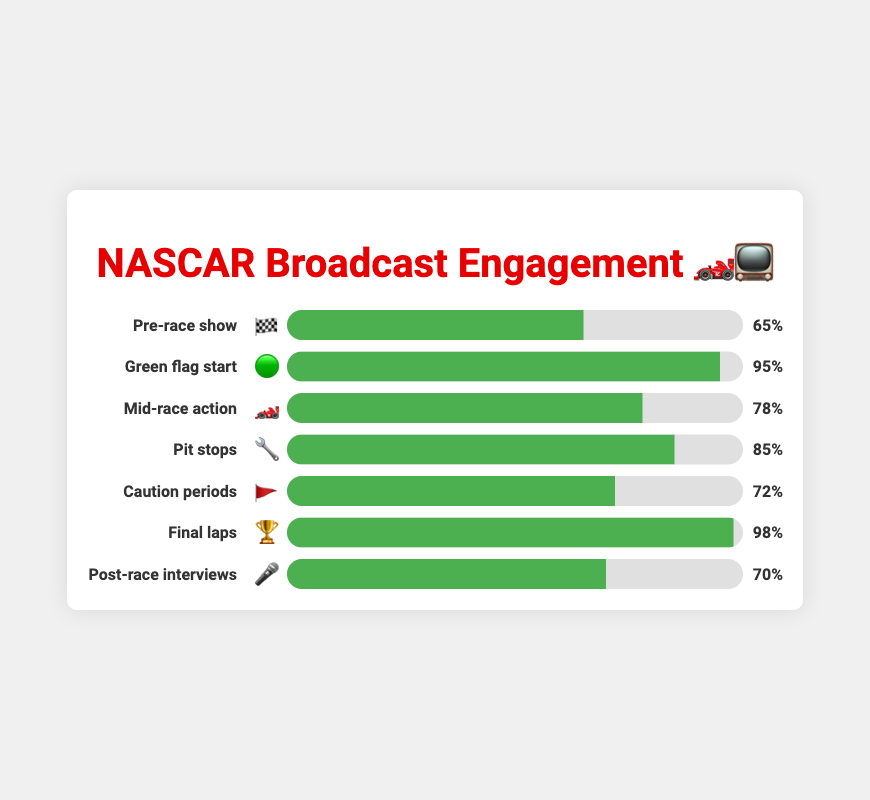What is the engagement rating for the Green flag start 🟢? The engagement rating for the Green flag start is shown on the bar chart. The progress bar is noted at 95%.
Answer: 95% Which segment has the highest viewer engagement? First, scan all the segments' engagement ratings. The segment with the highest rating is the Final Laps, with 98%.
Answer: Final Laps How does the viewer engagement for Pit stops 🔧 compare to the Mid-race action 🏎️? Pit stops have an engagement rating of 85%, while Mid-race action has a rating of 78%. Comparing the two, 85% is greater than 78%.
Answer: Pit stops have higher engagement What is the difference in engagement between the Caution periods 🚩 and the Pre-race show 🏁? The engagement for Caution periods is 72%, and for the Pre-race show it's 65%. Subtracting these two values gives 72% - 65% = 7%.
Answer: 7% What is the average engagement across all segments? Add all the engagement ratings: 65 + 95 + 78 + 85 + 72 + 98 + 70 = 563. Divide by the number of segments, which is 7. The average is 563/7 ≈ 80.43%.
Answer: 80.43% Which segment has the lowest viewer engagement and what is the rating? The segment with the lowest rating is found by scanning through all segments. The Pre-race show has the lowest engagement at 65%.
Answer: Pre-race show, 65% How much more engaging are the Final laps 🏆 compared to the Post-race interviews 🎤? The Final laps have an engagement rating of 98%, and Post-race interviews have 70%. Subtract these two values: 98% - 70% = 28%.
Answer: 28% more engaging Arrange the segments in descending order of their engagement ratings. List the segments by comparing their engagement ratings and ordering them from highest to lowest: Final Laps (98%), Green flag start (95%), Pit stops (85%), Mid-race action (78%), Caution periods (72%), Post-race interviews (70%), Pre-race show (65%).
Answer: Final Laps, Green flag start, Pit stops, Mid-race action, Caution periods, Post-race interviews, Pre-race show 